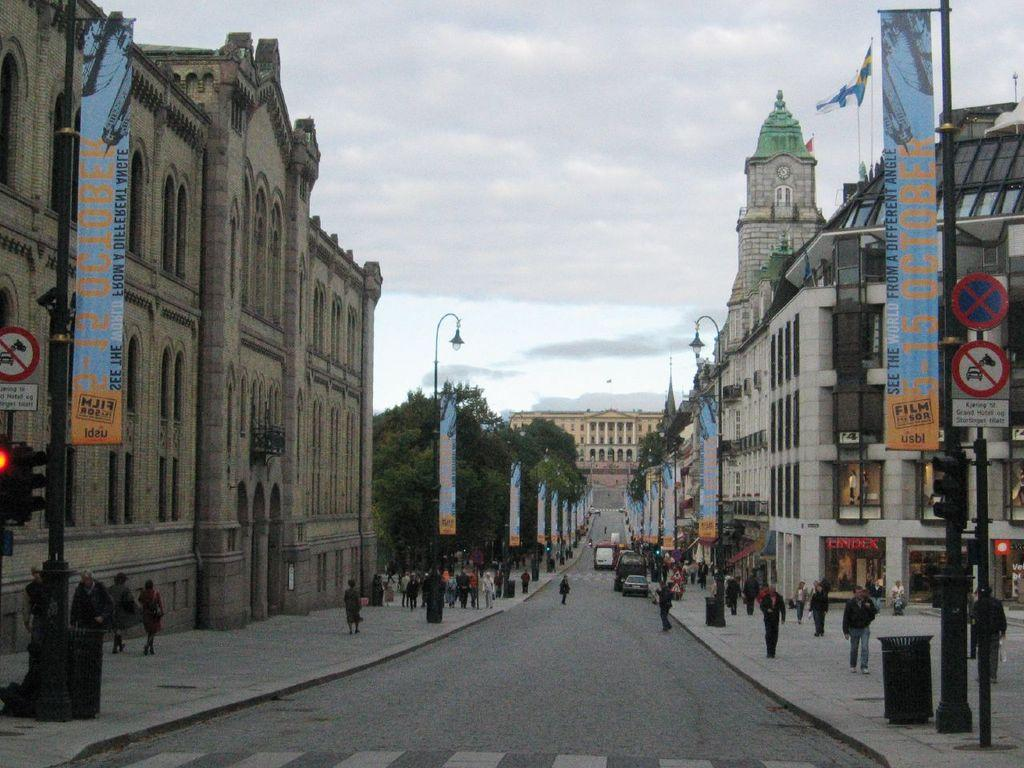What can be seen on the roadside in the image? There are vehicles on the roadside in the image. What are the people in the image doing? There are people walking in the image. What type of structures can be seen in the image? There are buildings visible in the image. What kind of signage is present in the image? Banners and boards are present in the image. What type of vegetation is visible in the image? Trees are visible in the image. How many lizards can be seen climbing on the buildings in the image? There are no lizards present in the image. What type of wrist accessory is worn by the people walking in the image? The image does not provide information about any wrist accessories worn by the people walking. 